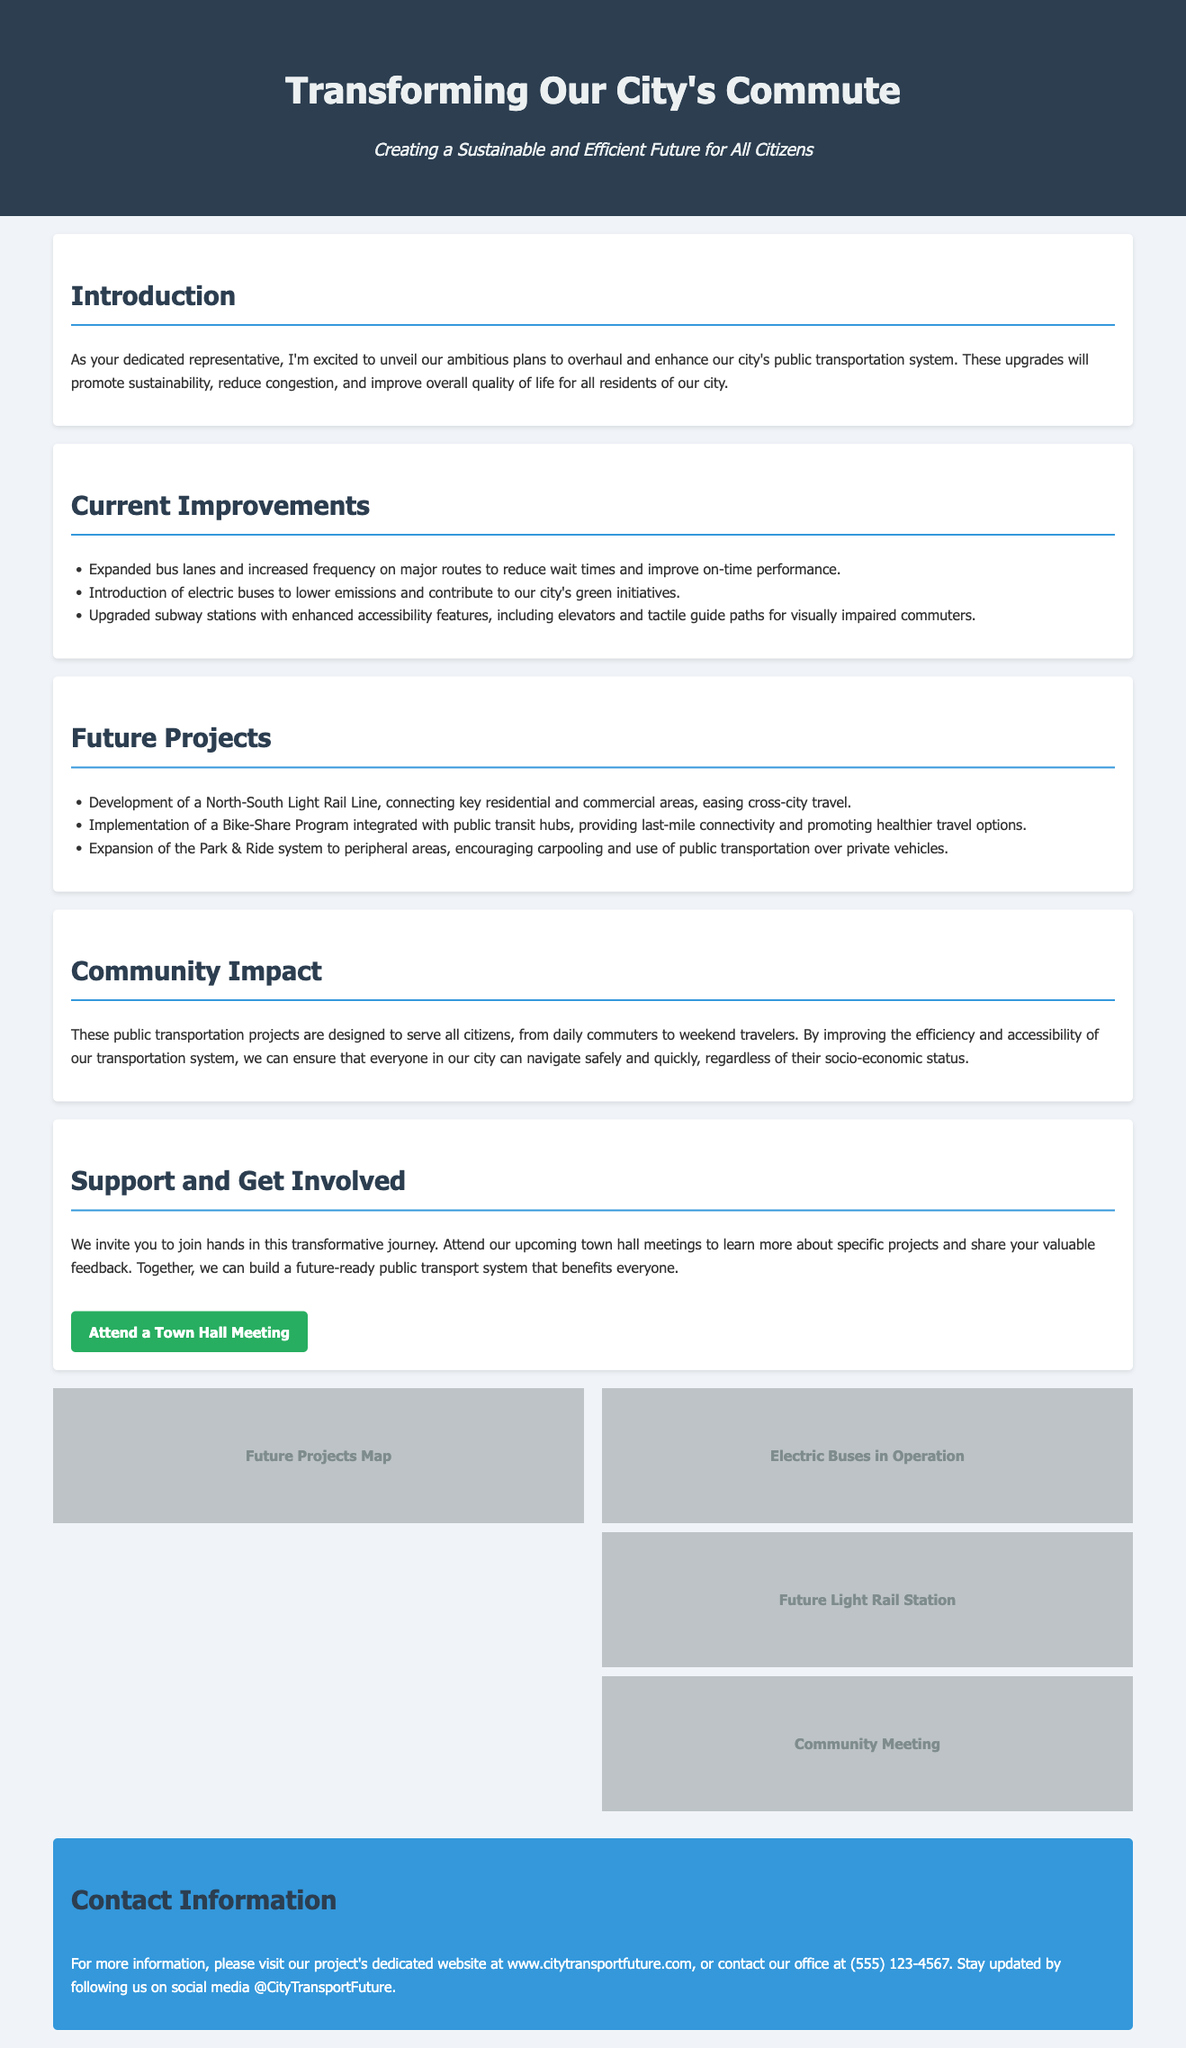What is the title of the advertisement? The title of the advertisement is prominently displayed at the top of the document.
Answer: Transforming Our City's Commute What is the subheadline of the advertisement? The subheadline summarizes the main focus of the advertisement in an encouraging tone.
Answer: Creating a Sustainable and Efficient Future for All Citizens How many improvements are currently listed? The document includes a bullet list that details the current improvements in the transportation system.
Answer: Three What type of buses is being introduced? The document states that new buses are being integrated into the transportation system, specifically highlighting their environmental benefit.
Answer: Electric buses What is one future project mentioned? The document describes several future projects aimed at enhancing public transportation in the city.
Answer: North-South Light Rail Line What is the purpose of the Bike-Share Program? The purpose is outlined as a goal for integrating with public transport to enhance connectivity.
Answer: Last-mile connectivity What does the community impact section emphasize? This section highlights the overarching goal of the project and the intended beneficiaries.
Answer: Overall quality of life for all residents How can citizens get involved? The advertisement provides specific ways for community members to engage with the project.
Answer: Attend town hall meetings What is the contact phone number provided? The document includes contact information for further inquiries about the project.
Answer: (555) 123-4567 What theme is emphasized in the advertisement's main message? The advertisement communicates an overarching theme related to the planned transit system upgrades.
Answer: Sustainability 